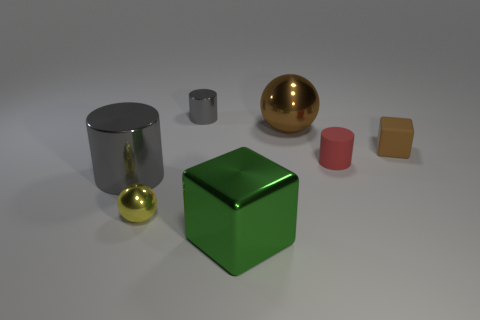Add 3 big green objects. How many objects exist? 10 Subtract all cylinders. How many objects are left? 4 Add 4 blue shiny cylinders. How many blue shiny cylinders exist? 4 Subtract 0 purple cubes. How many objects are left? 7 Subtract all big brown matte cubes. Subtract all shiny objects. How many objects are left? 2 Add 6 small blocks. How many small blocks are left? 7 